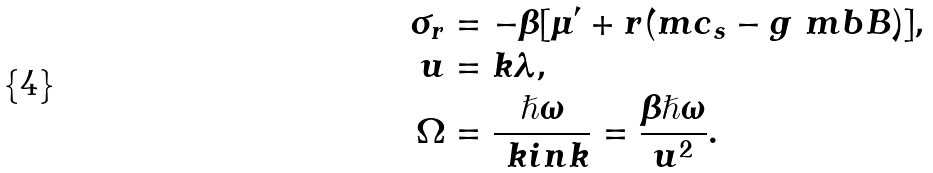Convert formula to latex. <formula><loc_0><loc_0><loc_500><loc_500>\sigma _ { r } & = - \beta [ \mu ^ { \prime } + r ( m c _ { s } - g \ m b B ) ] , \\ u & = k \lambda , \\ \Omega & = \frac { \hslash \omega } { \ k i n k } = \frac { \beta \hslash \omega } { u ^ { 2 } } .</formula> 